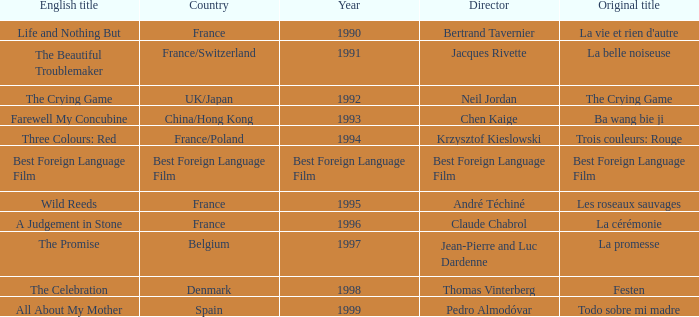What's the Original Title of the English title A Judgement in Stone? La cérémonie. 